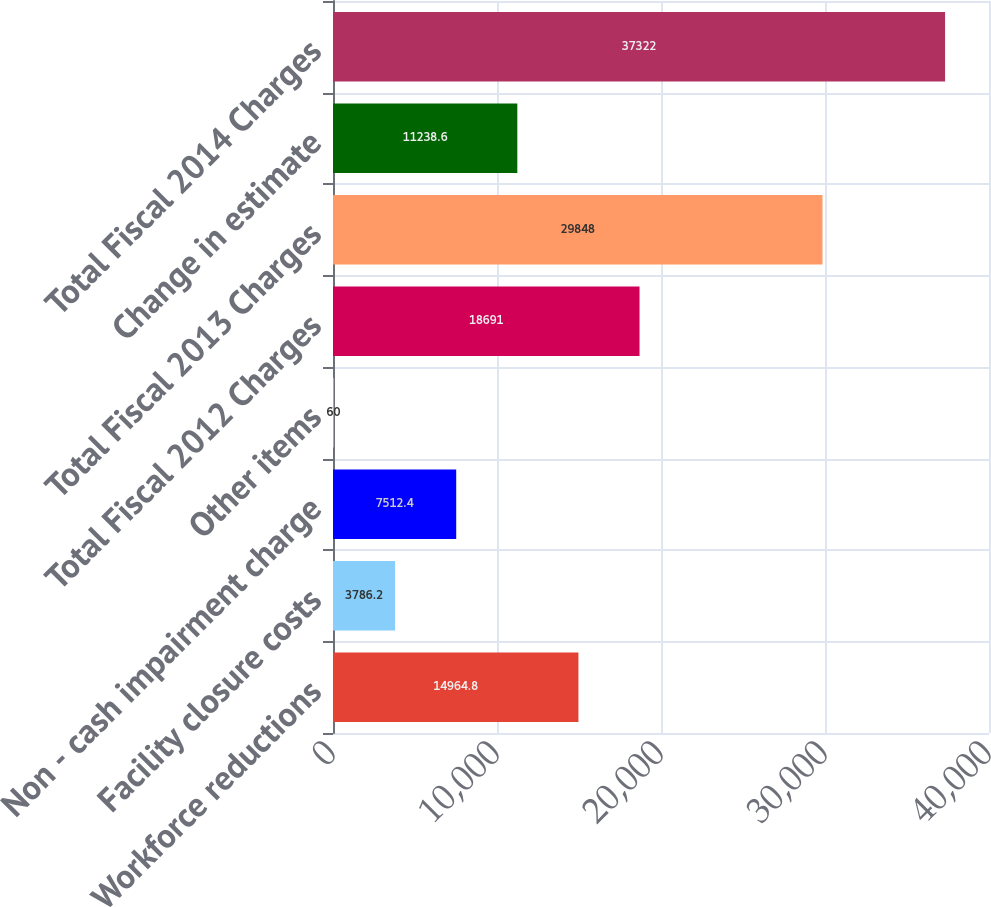Convert chart. <chart><loc_0><loc_0><loc_500><loc_500><bar_chart><fcel>Workforce reductions<fcel>Facility closure costs<fcel>Non - cash impairment charge<fcel>Other items<fcel>Total Fiscal 2012 Charges<fcel>Total Fiscal 2013 Charges<fcel>Change in estimate<fcel>Total Fiscal 2014 Charges<nl><fcel>14964.8<fcel>3786.2<fcel>7512.4<fcel>60<fcel>18691<fcel>29848<fcel>11238.6<fcel>37322<nl></chart> 